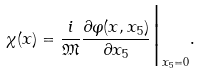Convert formula to latex. <formula><loc_0><loc_0><loc_500><loc_500>\chi ( x ) = \frac { i } { \mathfrak { M } } \frac { \partial \varphi ( x , x _ { 5 } ) } { \partial x _ { 5 } } \Big | _ { x _ { 5 } = 0 } .</formula> 